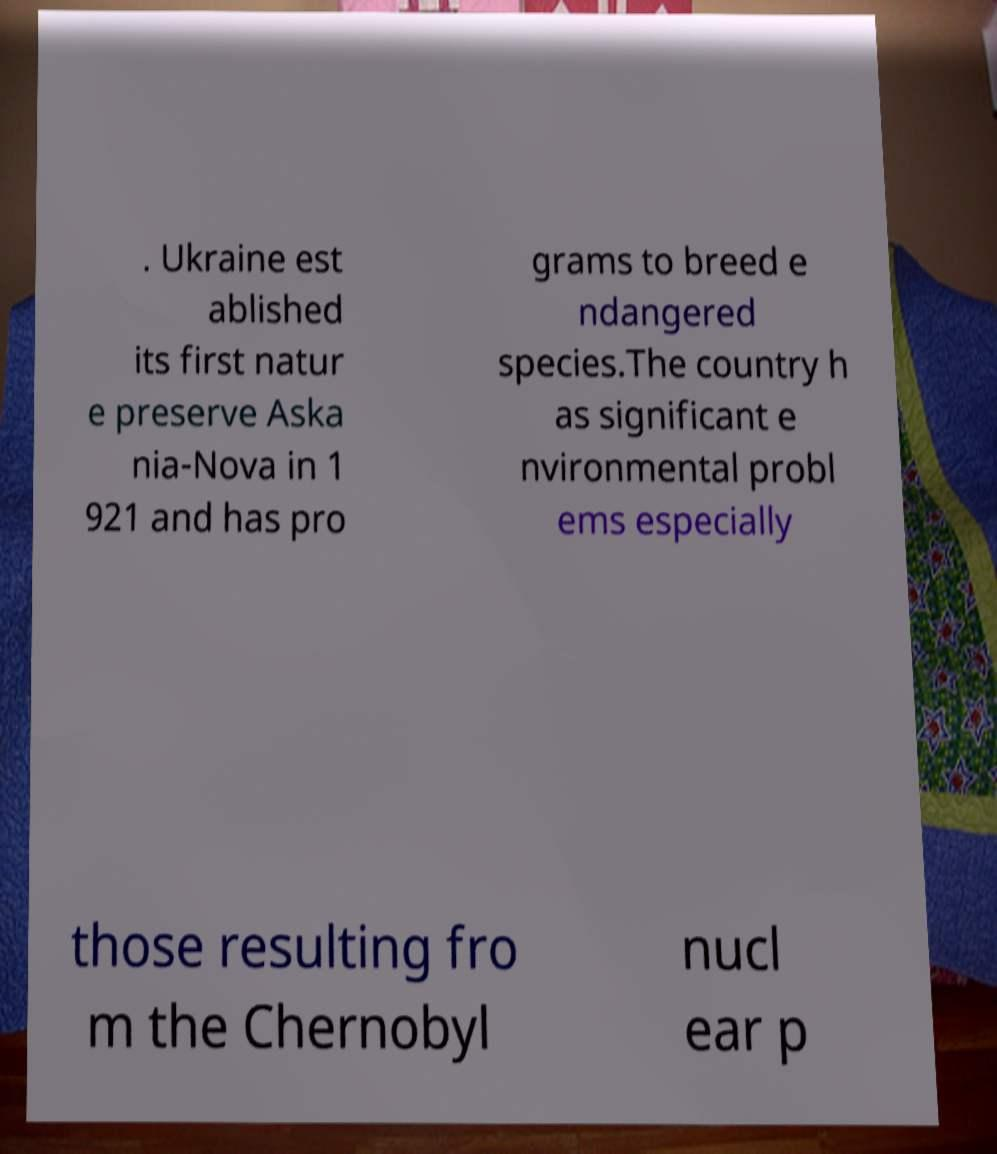What messages or text are displayed in this image? I need them in a readable, typed format. . Ukraine est ablished its first natur e preserve Aska nia-Nova in 1 921 and has pro grams to breed e ndangered species.The country h as significant e nvironmental probl ems especially those resulting fro m the Chernobyl nucl ear p 